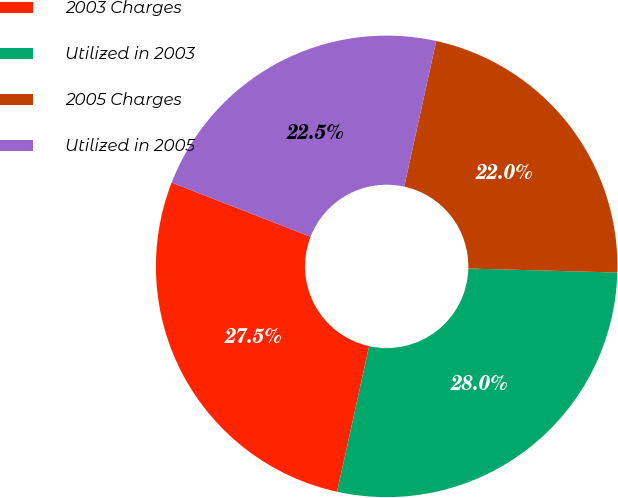Convert chart. <chart><loc_0><loc_0><loc_500><loc_500><pie_chart><fcel>2003 Charges<fcel>Utilized in 2003<fcel>2005 Charges<fcel>Utilized in 2005<nl><fcel>27.47%<fcel>28.02%<fcel>21.98%<fcel>22.53%<nl></chart> 